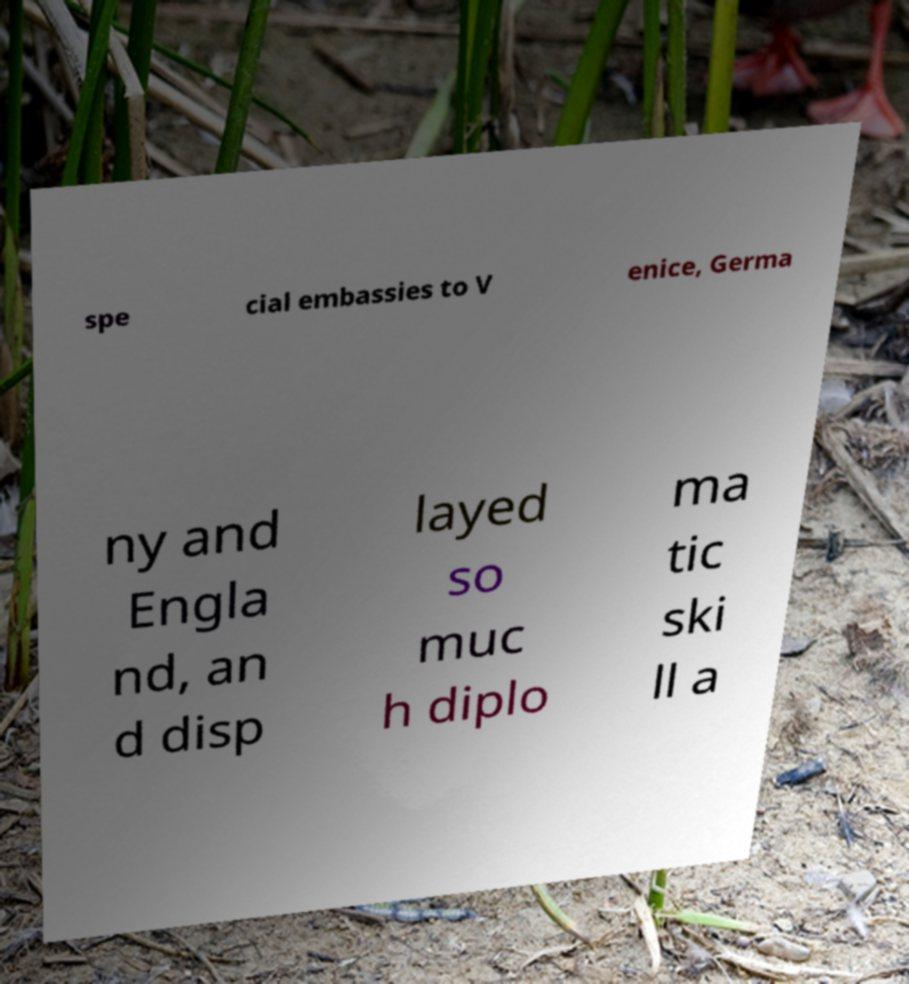Can you read and provide the text displayed in the image?This photo seems to have some interesting text. Can you extract and type it out for me? spe cial embassies to V enice, Germa ny and Engla nd, an d disp layed so muc h diplo ma tic ski ll a 